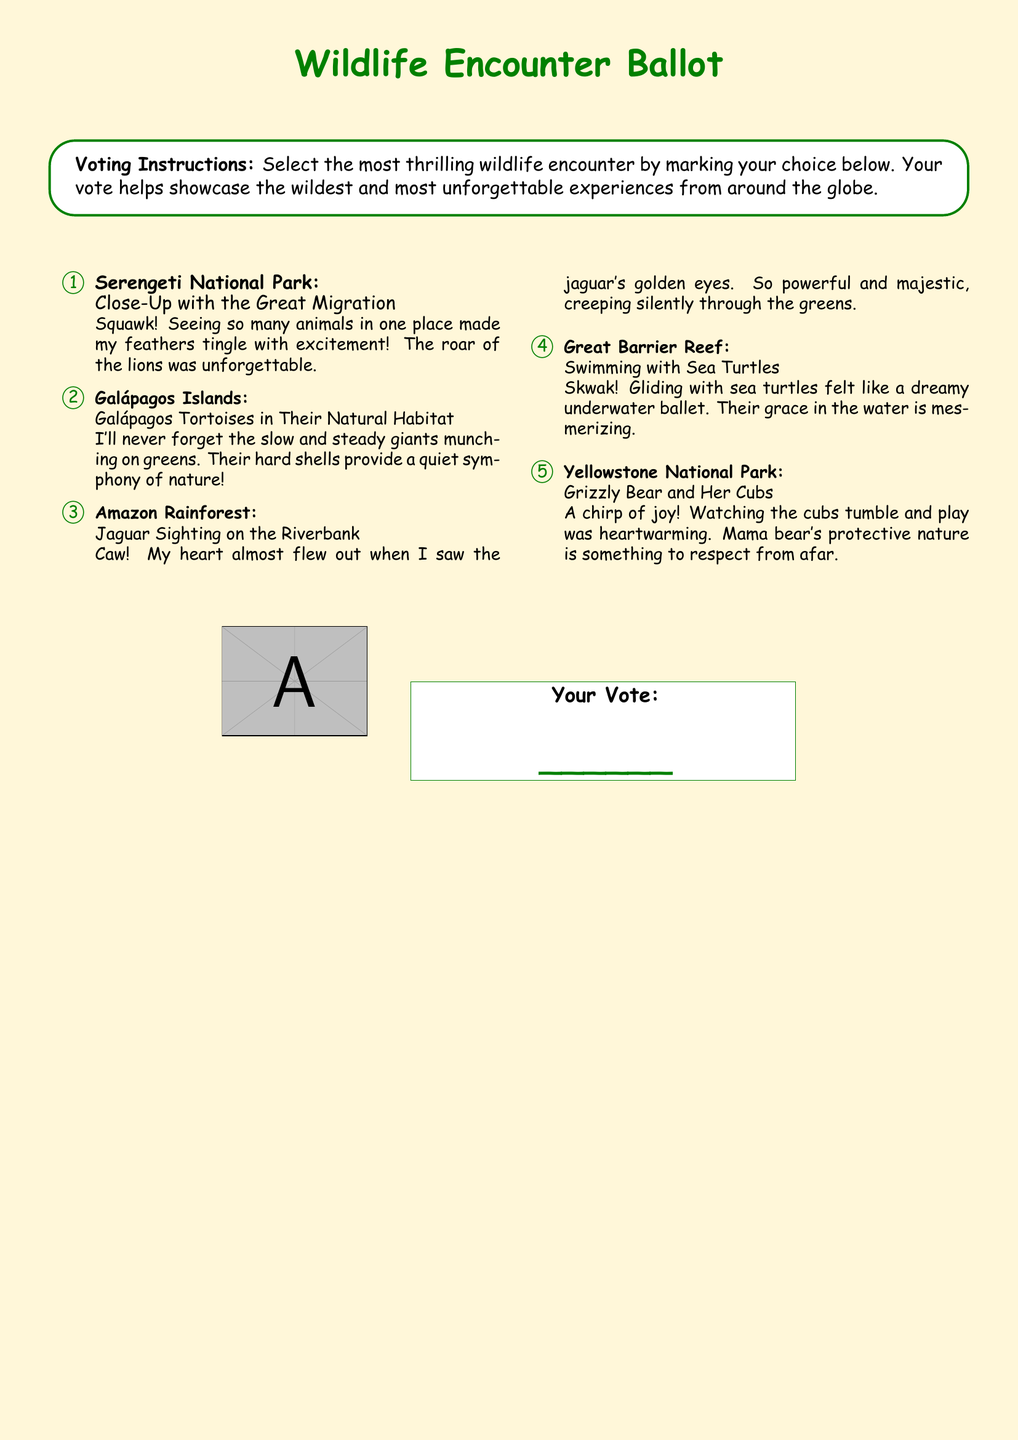What is the title of the ballot? The title of the ballot is presented in a large font at the top of the document.
Answer: Wildlife Encounter Ballot How many wildlife encounters are listed? The number of encounters is indicated by the enumeration within the document.
Answer: 5 What encounter takes place in the Galápagos Islands? The encounter listed under the Galápagos Islands provides a specific example of wildlife.
Answer: Galápagos Tortoises in Their Natural Habitat Which wildlife sighting made the parrot's heart race? This information can be found in the description of a specific encounter mentioned in the document.
Answer: Jaguar Sighting on the Riverbank What color is the background of the document? The background color is described in the formatting details of the document.
Answer: Light yellow 